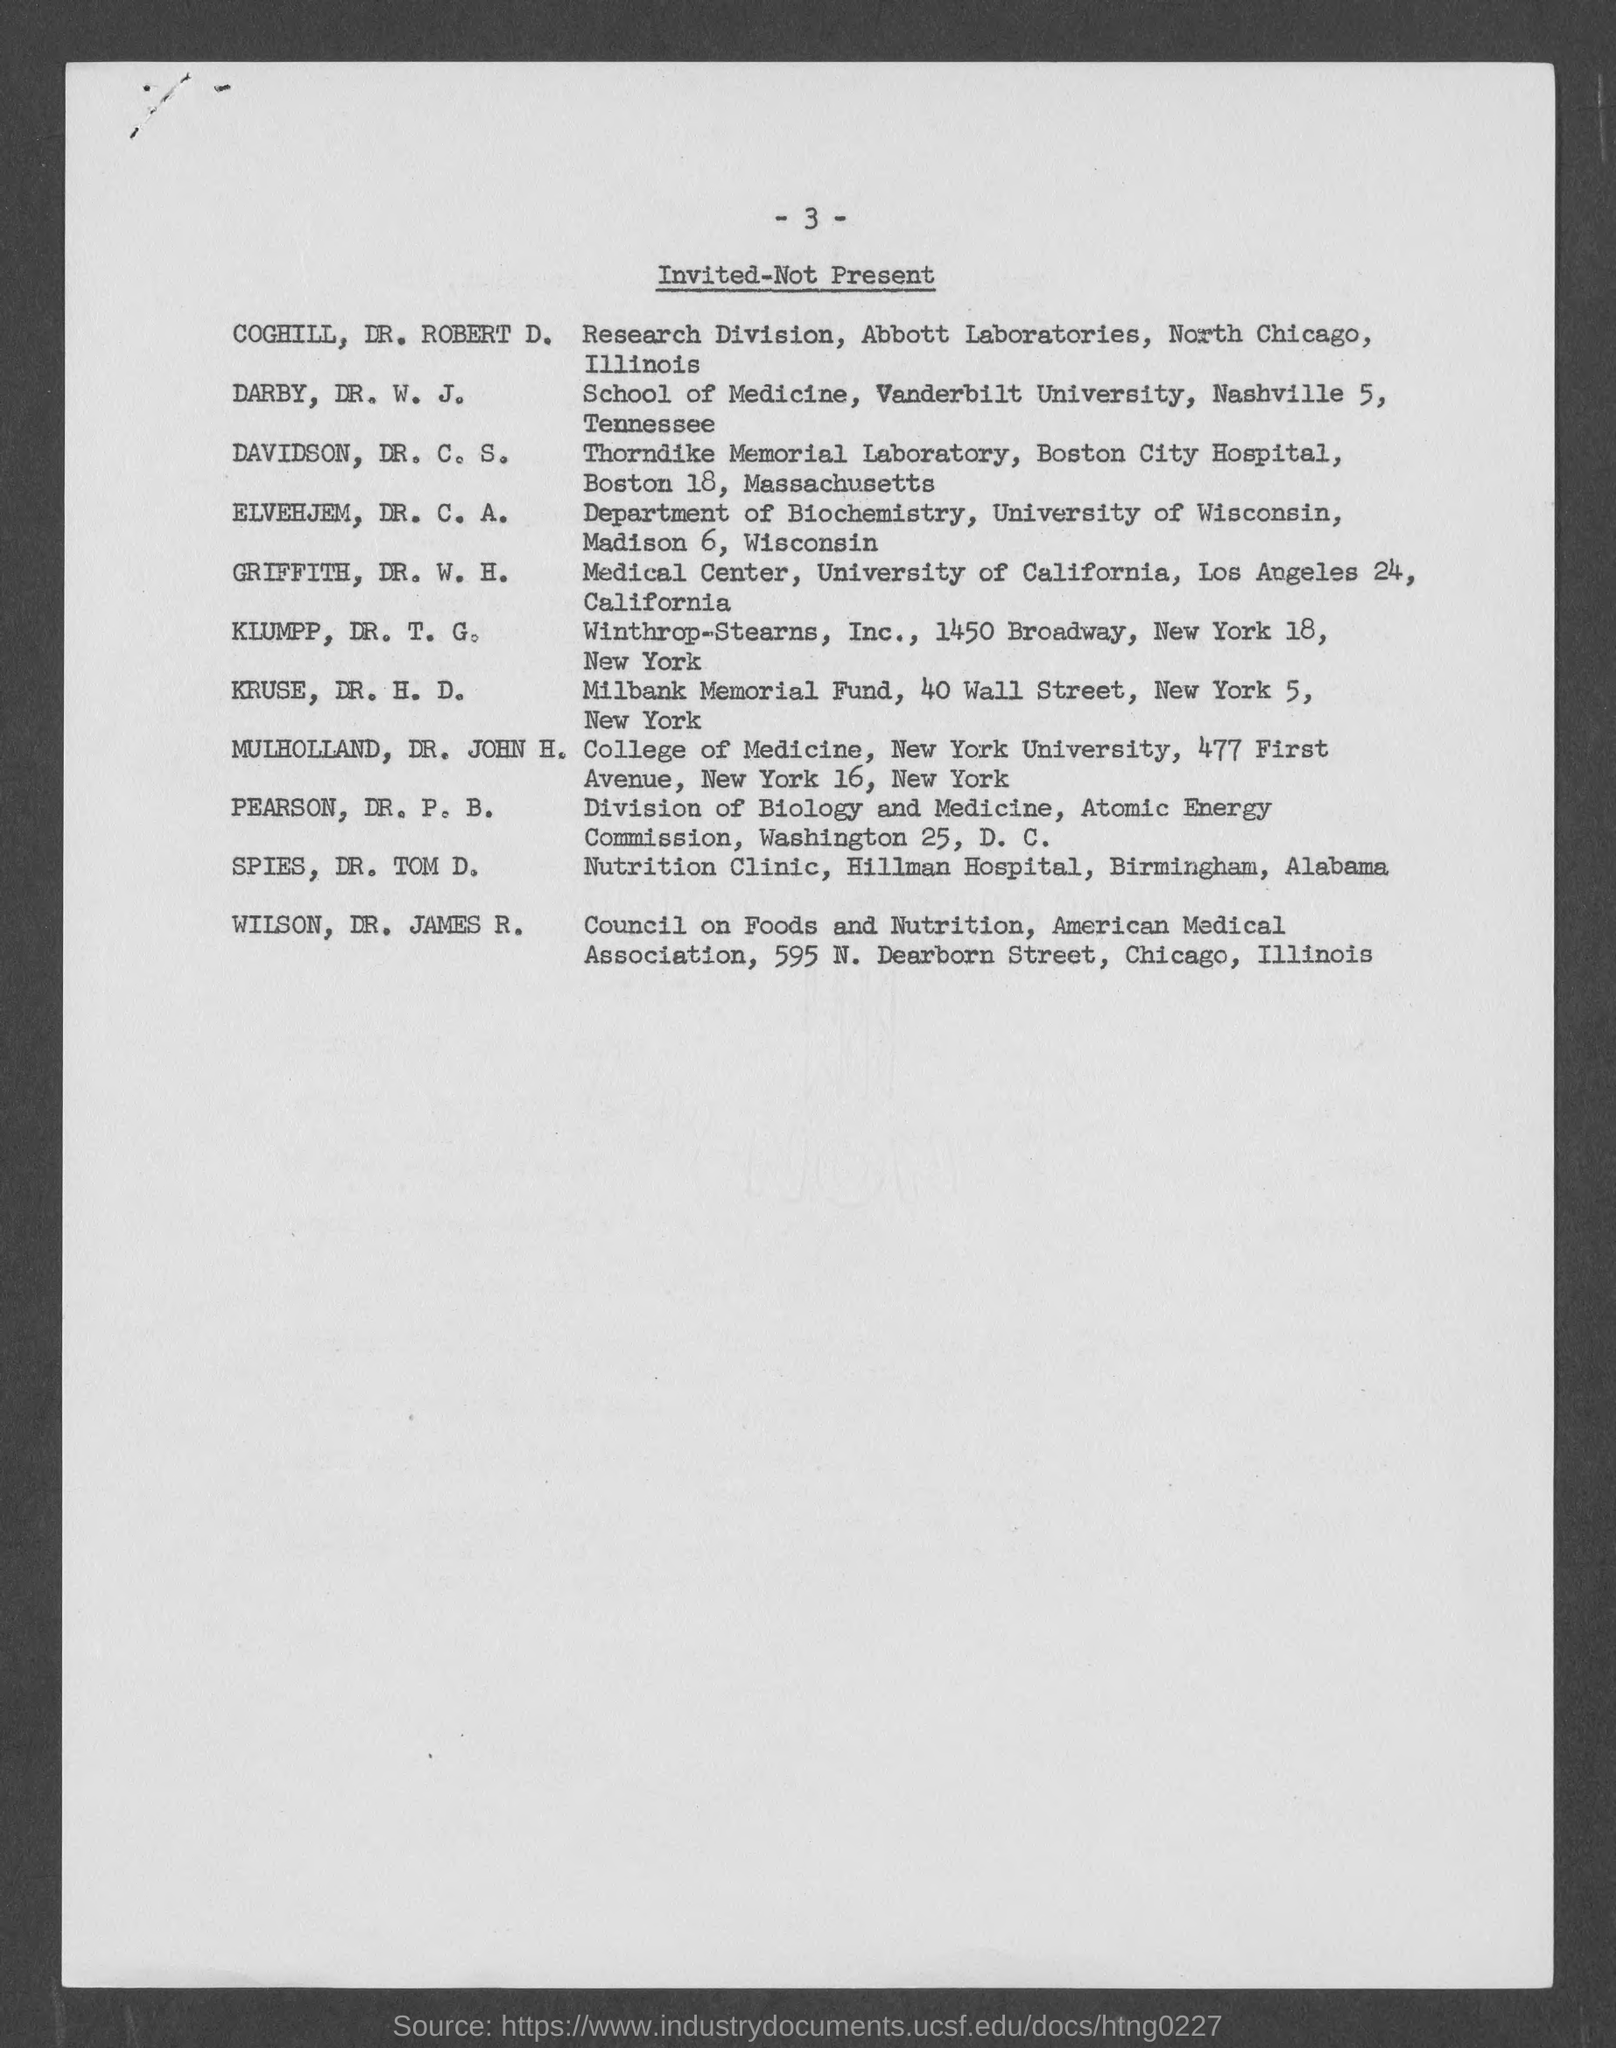List of which category of people is shown in the document ?
Give a very brief answer. Invited-not present. In which department, did "ELVEHJEM, DR. C. A." works?
Your answer should be compact. Department of biochemistry. In which hospital, did "SPIES, DR. TOM D. " works ?
Your response must be concise. Hillman Hospital. In which hospital, did "DAVIDSON, DR. C. S." works ?
Make the answer very short. Boston City Hospital. In which university, did " GRIFFITH, DR. W. H." works?
Your response must be concise. University of california. In which council, did "WILSON, DR. JAMES R." belongs to?
Ensure brevity in your answer.  Council on foods and nutrition. In which university, does "College of Medicine" belongs to ?
Your response must be concise. New york university. In which university, does "School of Medicine" belongs to ?
Make the answer very short. Vanderbilt University. 